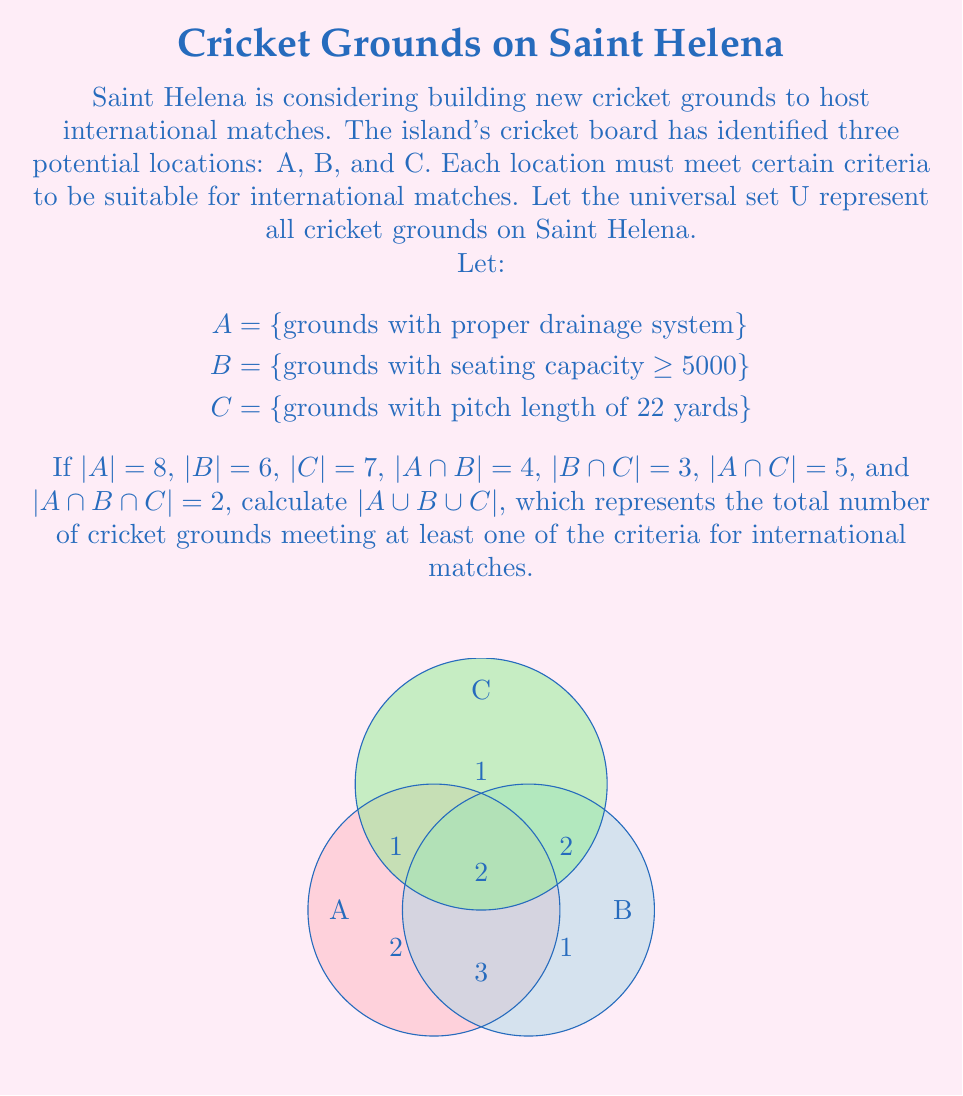What is the answer to this math problem? To solve this problem, we'll use the Inclusion-Exclusion Principle for three sets:

$$|A ∪ B ∪ C| = |A| + |B| + |C| - |A ∩ B| - |B ∩ C| - |A ∩ C| + |A ∩ B ∩ C|$$

Let's substitute the given values:

1) |A| = 8
2) |B| = 6
3) |C| = 7
4) |A ∩ B| = 4
5) |B ∩ C| = 3
6) |A ∩ C| = 5
7) |A ∩ B ∩ C| = 2

Now, let's apply the formula:

$$|A ∪ B ∪ C| = 8 + 6 + 7 - 4 - 3 - 5 + 2$$

Simplifying:
$$|A ∪ B ∪ C| = 21 - 12 + 2 = 11$$

Therefore, there are 11 cricket grounds in total that meet at least one of the criteria for international matches.
Answer: 11 